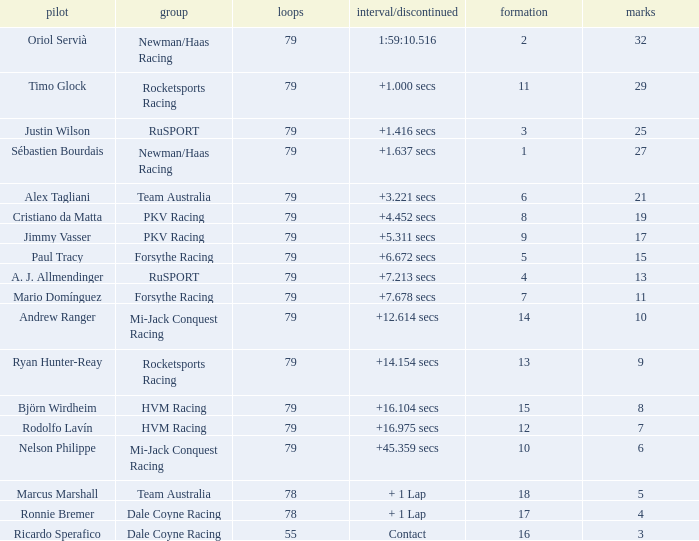Which points has the driver Paul Tracy? 15.0. 